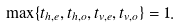Convert formula to latex. <formula><loc_0><loc_0><loc_500><loc_500>\max \{ t _ { h , e } , t _ { h , o } , t _ { v , e } , t _ { v , o } \} = 1 .</formula> 